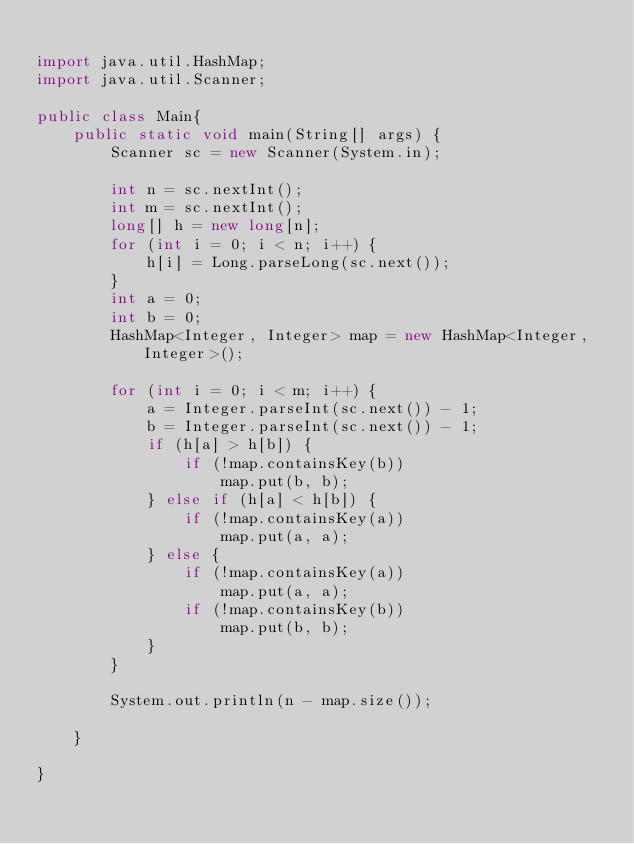Convert code to text. <code><loc_0><loc_0><loc_500><loc_500><_Java_>
import java.util.HashMap;
import java.util.Scanner;

public class Main{
	public static void main(String[] args) {
		Scanner sc = new Scanner(System.in);

		int n = sc.nextInt();
		int m = sc.nextInt();
		long[] h = new long[n];
		for (int i = 0; i < n; i++) {
			h[i] = Long.parseLong(sc.next());
		}
		int a = 0;
		int b = 0;
		HashMap<Integer, Integer> map = new HashMap<Integer, Integer>();

		for (int i = 0; i < m; i++) {
			a = Integer.parseInt(sc.next()) - 1;
			b = Integer.parseInt(sc.next()) - 1;
			if (h[a] > h[b]) {
				if (!map.containsKey(b))
					map.put(b, b);
			} else if (h[a] < h[b]) {
				if (!map.containsKey(a))
					map.put(a, a);
			} else {
				if (!map.containsKey(a))
					map.put(a, a);
				if (!map.containsKey(b))
					map.put(b, b);
			}
		}

		System.out.println(n - map.size());

	}

}
</code> 